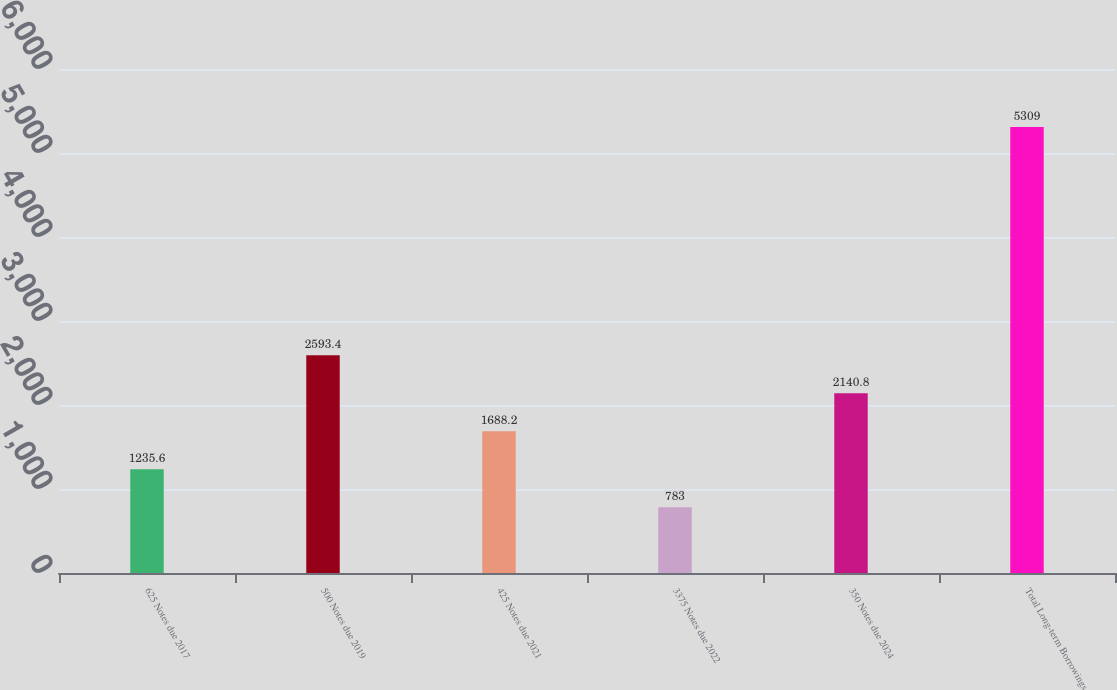<chart> <loc_0><loc_0><loc_500><loc_500><bar_chart><fcel>625 Notes due 2017<fcel>500 Notes due 2019<fcel>425 Notes due 2021<fcel>3375 Notes due 2022<fcel>350 Notes due 2024<fcel>Total Long-term Borrowings<nl><fcel>1235.6<fcel>2593.4<fcel>1688.2<fcel>783<fcel>2140.8<fcel>5309<nl></chart> 